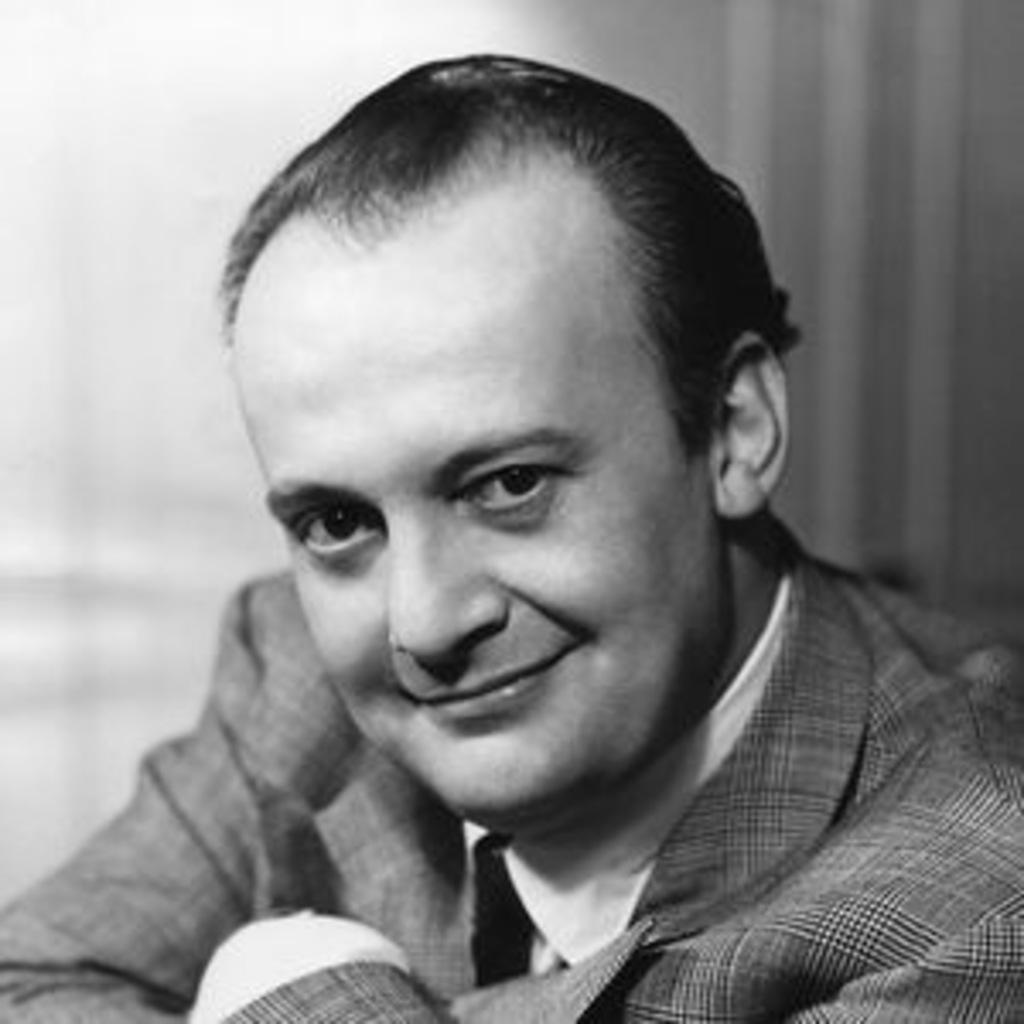What is the color scheme of the image? The image is black and white. Can you describe the person in the image? There is a person in the image, and they are wearing a blazer. What can be said about the background of the image? The background of the image is blurry. What type of grass can be seen in the image? There is no grass present in the image; it is a black and white image of a person wearing a blazer with a blurry background. 